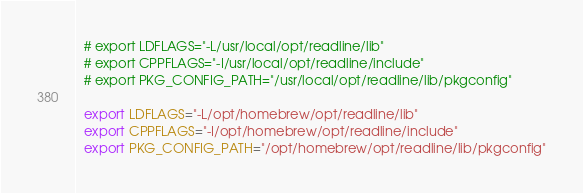Convert code to text. <code><loc_0><loc_0><loc_500><loc_500><_Bash_>  # export LDFLAGS="-L/usr/local/opt/readline/lib"
  # export CPPFLAGS="-I/usr/local/opt/readline/include"
  # export PKG_CONFIG_PATH="/usr/local/opt/readline/lib/pkgconfig"

  export LDFLAGS="-L/opt/homebrew/opt/readline/lib"
  export CPPFLAGS="-I/opt/homebrew/opt/readline/include"
  export PKG_CONFIG_PATH="/opt/homebrew/opt/readline/lib/pkgconfig"
</code> 